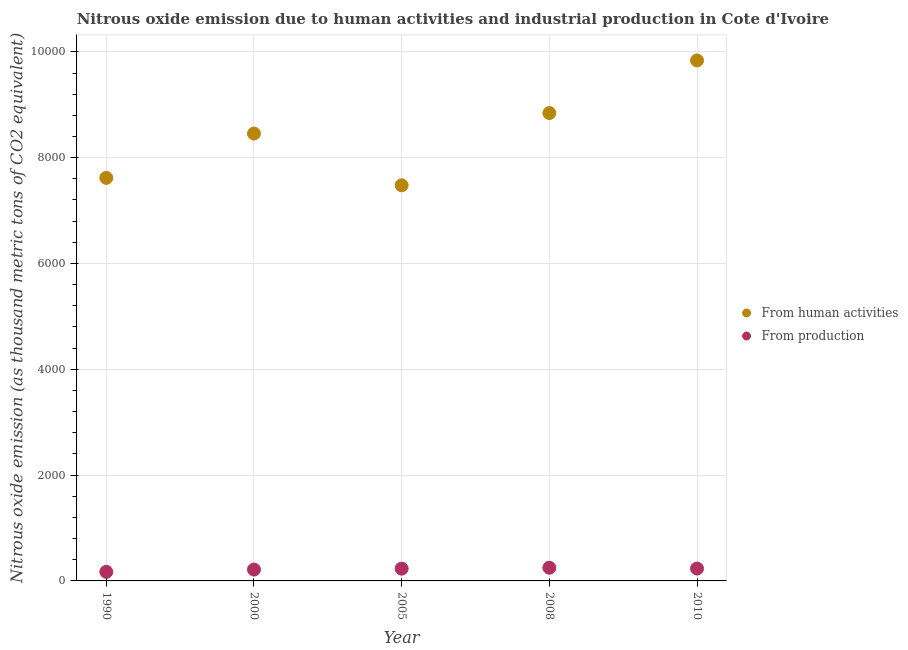Is the number of dotlines equal to the number of legend labels?
Your answer should be compact. Yes. What is the amount of emissions generated from industries in 2005?
Offer a very short reply. 231.8. Across all years, what is the maximum amount of emissions from human activities?
Your answer should be compact. 9837.4. Across all years, what is the minimum amount of emissions from human activities?
Provide a succinct answer. 7477.7. What is the total amount of emissions from human activities in the graph?
Make the answer very short. 4.22e+04. What is the difference between the amount of emissions from human activities in 2005 and that in 2010?
Ensure brevity in your answer.  -2359.7. What is the difference between the amount of emissions generated from industries in 1990 and the amount of emissions from human activities in 2005?
Offer a terse response. -7306.1. What is the average amount of emissions from human activities per year?
Offer a terse response. 8446.42. In the year 2008, what is the difference between the amount of emissions generated from industries and amount of emissions from human activities?
Offer a very short reply. -8594.1. What is the ratio of the amount of emissions generated from industries in 2005 to that in 2008?
Ensure brevity in your answer.  0.93. Is the difference between the amount of emissions from human activities in 1990 and 2010 greater than the difference between the amount of emissions generated from industries in 1990 and 2010?
Your response must be concise. No. What is the difference between the highest and the second highest amount of emissions from human activities?
Provide a short and direct response. 994.1. What is the difference between the highest and the lowest amount of emissions generated from industries?
Keep it short and to the point. 77.6. In how many years, is the amount of emissions generated from industries greater than the average amount of emissions generated from industries taken over all years?
Offer a very short reply. 3. Is the amount of emissions from human activities strictly greater than the amount of emissions generated from industries over the years?
Provide a short and direct response. Yes. What is the difference between two consecutive major ticks on the Y-axis?
Offer a terse response. 2000. How many legend labels are there?
Offer a terse response. 2. What is the title of the graph?
Offer a very short reply. Nitrous oxide emission due to human activities and industrial production in Cote d'Ivoire. What is the label or title of the Y-axis?
Make the answer very short. Nitrous oxide emission (as thousand metric tons of CO2 equivalent). What is the Nitrous oxide emission (as thousand metric tons of CO2 equivalent) in From human activities in 1990?
Keep it short and to the point. 7618. What is the Nitrous oxide emission (as thousand metric tons of CO2 equivalent) in From production in 1990?
Keep it short and to the point. 171.6. What is the Nitrous oxide emission (as thousand metric tons of CO2 equivalent) in From human activities in 2000?
Provide a succinct answer. 8455.7. What is the Nitrous oxide emission (as thousand metric tons of CO2 equivalent) of From production in 2000?
Provide a short and direct response. 214.7. What is the Nitrous oxide emission (as thousand metric tons of CO2 equivalent) of From human activities in 2005?
Offer a terse response. 7477.7. What is the Nitrous oxide emission (as thousand metric tons of CO2 equivalent) of From production in 2005?
Keep it short and to the point. 231.8. What is the Nitrous oxide emission (as thousand metric tons of CO2 equivalent) in From human activities in 2008?
Your answer should be compact. 8843.3. What is the Nitrous oxide emission (as thousand metric tons of CO2 equivalent) of From production in 2008?
Make the answer very short. 249.2. What is the Nitrous oxide emission (as thousand metric tons of CO2 equivalent) of From human activities in 2010?
Your response must be concise. 9837.4. What is the Nitrous oxide emission (as thousand metric tons of CO2 equivalent) in From production in 2010?
Offer a terse response. 233.8. Across all years, what is the maximum Nitrous oxide emission (as thousand metric tons of CO2 equivalent) in From human activities?
Your response must be concise. 9837.4. Across all years, what is the maximum Nitrous oxide emission (as thousand metric tons of CO2 equivalent) of From production?
Offer a very short reply. 249.2. Across all years, what is the minimum Nitrous oxide emission (as thousand metric tons of CO2 equivalent) in From human activities?
Provide a succinct answer. 7477.7. Across all years, what is the minimum Nitrous oxide emission (as thousand metric tons of CO2 equivalent) in From production?
Your response must be concise. 171.6. What is the total Nitrous oxide emission (as thousand metric tons of CO2 equivalent) in From human activities in the graph?
Offer a very short reply. 4.22e+04. What is the total Nitrous oxide emission (as thousand metric tons of CO2 equivalent) in From production in the graph?
Your response must be concise. 1101.1. What is the difference between the Nitrous oxide emission (as thousand metric tons of CO2 equivalent) of From human activities in 1990 and that in 2000?
Your response must be concise. -837.7. What is the difference between the Nitrous oxide emission (as thousand metric tons of CO2 equivalent) in From production in 1990 and that in 2000?
Your answer should be very brief. -43.1. What is the difference between the Nitrous oxide emission (as thousand metric tons of CO2 equivalent) in From human activities in 1990 and that in 2005?
Give a very brief answer. 140.3. What is the difference between the Nitrous oxide emission (as thousand metric tons of CO2 equivalent) in From production in 1990 and that in 2005?
Offer a terse response. -60.2. What is the difference between the Nitrous oxide emission (as thousand metric tons of CO2 equivalent) in From human activities in 1990 and that in 2008?
Provide a succinct answer. -1225.3. What is the difference between the Nitrous oxide emission (as thousand metric tons of CO2 equivalent) in From production in 1990 and that in 2008?
Your answer should be compact. -77.6. What is the difference between the Nitrous oxide emission (as thousand metric tons of CO2 equivalent) in From human activities in 1990 and that in 2010?
Your answer should be very brief. -2219.4. What is the difference between the Nitrous oxide emission (as thousand metric tons of CO2 equivalent) in From production in 1990 and that in 2010?
Give a very brief answer. -62.2. What is the difference between the Nitrous oxide emission (as thousand metric tons of CO2 equivalent) in From human activities in 2000 and that in 2005?
Provide a short and direct response. 978. What is the difference between the Nitrous oxide emission (as thousand metric tons of CO2 equivalent) of From production in 2000 and that in 2005?
Keep it short and to the point. -17.1. What is the difference between the Nitrous oxide emission (as thousand metric tons of CO2 equivalent) in From human activities in 2000 and that in 2008?
Your answer should be compact. -387.6. What is the difference between the Nitrous oxide emission (as thousand metric tons of CO2 equivalent) in From production in 2000 and that in 2008?
Give a very brief answer. -34.5. What is the difference between the Nitrous oxide emission (as thousand metric tons of CO2 equivalent) in From human activities in 2000 and that in 2010?
Your answer should be very brief. -1381.7. What is the difference between the Nitrous oxide emission (as thousand metric tons of CO2 equivalent) in From production in 2000 and that in 2010?
Provide a short and direct response. -19.1. What is the difference between the Nitrous oxide emission (as thousand metric tons of CO2 equivalent) in From human activities in 2005 and that in 2008?
Offer a terse response. -1365.6. What is the difference between the Nitrous oxide emission (as thousand metric tons of CO2 equivalent) in From production in 2005 and that in 2008?
Keep it short and to the point. -17.4. What is the difference between the Nitrous oxide emission (as thousand metric tons of CO2 equivalent) of From human activities in 2005 and that in 2010?
Give a very brief answer. -2359.7. What is the difference between the Nitrous oxide emission (as thousand metric tons of CO2 equivalent) in From production in 2005 and that in 2010?
Your answer should be very brief. -2. What is the difference between the Nitrous oxide emission (as thousand metric tons of CO2 equivalent) in From human activities in 2008 and that in 2010?
Offer a very short reply. -994.1. What is the difference between the Nitrous oxide emission (as thousand metric tons of CO2 equivalent) of From human activities in 1990 and the Nitrous oxide emission (as thousand metric tons of CO2 equivalent) of From production in 2000?
Provide a short and direct response. 7403.3. What is the difference between the Nitrous oxide emission (as thousand metric tons of CO2 equivalent) of From human activities in 1990 and the Nitrous oxide emission (as thousand metric tons of CO2 equivalent) of From production in 2005?
Make the answer very short. 7386.2. What is the difference between the Nitrous oxide emission (as thousand metric tons of CO2 equivalent) of From human activities in 1990 and the Nitrous oxide emission (as thousand metric tons of CO2 equivalent) of From production in 2008?
Provide a short and direct response. 7368.8. What is the difference between the Nitrous oxide emission (as thousand metric tons of CO2 equivalent) in From human activities in 1990 and the Nitrous oxide emission (as thousand metric tons of CO2 equivalent) in From production in 2010?
Your response must be concise. 7384.2. What is the difference between the Nitrous oxide emission (as thousand metric tons of CO2 equivalent) in From human activities in 2000 and the Nitrous oxide emission (as thousand metric tons of CO2 equivalent) in From production in 2005?
Offer a very short reply. 8223.9. What is the difference between the Nitrous oxide emission (as thousand metric tons of CO2 equivalent) in From human activities in 2000 and the Nitrous oxide emission (as thousand metric tons of CO2 equivalent) in From production in 2008?
Make the answer very short. 8206.5. What is the difference between the Nitrous oxide emission (as thousand metric tons of CO2 equivalent) of From human activities in 2000 and the Nitrous oxide emission (as thousand metric tons of CO2 equivalent) of From production in 2010?
Keep it short and to the point. 8221.9. What is the difference between the Nitrous oxide emission (as thousand metric tons of CO2 equivalent) of From human activities in 2005 and the Nitrous oxide emission (as thousand metric tons of CO2 equivalent) of From production in 2008?
Your response must be concise. 7228.5. What is the difference between the Nitrous oxide emission (as thousand metric tons of CO2 equivalent) in From human activities in 2005 and the Nitrous oxide emission (as thousand metric tons of CO2 equivalent) in From production in 2010?
Give a very brief answer. 7243.9. What is the difference between the Nitrous oxide emission (as thousand metric tons of CO2 equivalent) of From human activities in 2008 and the Nitrous oxide emission (as thousand metric tons of CO2 equivalent) of From production in 2010?
Offer a terse response. 8609.5. What is the average Nitrous oxide emission (as thousand metric tons of CO2 equivalent) in From human activities per year?
Your answer should be compact. 8446.42. What is the average Nitrous oxide emission (as thousand metric tons of CO2 equivalent) in From production per year?
Your answer should be compact. 220.22. In the year 1990, what is the difference between the Nitrous oxide emission (as thousand metric tons of CO2 equivalent) in From human activities and Nitrous oxide emission (as thousand metric tons of CO2 equivalent) in From production?
Your response must be concise. 7446.4. In the year 2000, what is the difference between the Nitrous oxide emission (as thousand metric tons of CO2 equivalent) in From human activities and Nitrous oxide emission (as thousand metric tons of CO2 equivalent) in From production?
Ensure brevity in your answer.  8241. In the year 2005, what is the difference between the Nitrous oxide emission (as thousand metric tons of CO2 equivalent) in From human activities and Nitrous oxide emission (as thousand metric tons of CO2 equivalent) in From production?
Offer a terse response. 7245.9. In the year 2008, what is the difference between the Nitrous oxide emission (as thousand metric tons of CO2 equivalent) in From human activities and Nitrous oxide emission (as thousand metric tons of CO2 equivalent) in From production?
Provide a short and direct response. 8594.1. In the year 2010, what is the difference between the Nitrous oxide emission (as thousand metric tons of CO2 equivalent) in From human activities and Nitrous oxide emission (as thousand metric tons of CO2 equivalent) in From production?
Offer a terse response. 9603.6. What is the ratio of the Nitrous oxide emission (as thousand metric tons of CO2 equivalent) of From human activities in 1990 to that in 2000?
Offer a terse response. 0.9. What is the ratio of the Nitrous oxide emission (as thousand metric tons of CO2 equivalent) in From production in 1990 to that in 2000?
Keep it short and to the point. 0.8. What is the ratio of the Nitrous oxide emission (as thousand metric tons of CO2 equivalent) in From human activities in 1990 to that in 2005?
Offer a very short reply. 1.02. What is the ratio of the Nitrous oxide emission (as thousand metric tons of CO2 equivalent) of From production in 1990 to that in 2005?
Your answer should be very brief. 0.74. What is the ratio of the Nitrous oxide emission (as thousand metric tons of CO2 equivalent) of From human activities in 1990 to that in 2008?
Offer a very short reply. 0.86. What is the ratio of the Nitrous oxide emission (as thousand metric tons of CO2 equivalent) of From production in 1990 to that in 2008?
Offer a very short reply. 0.69. What is the ratio of the Nitrous oxide emission (as thousand metric tons of CO2 equivalent) in From human activities in 1990 to that in 2010?
Give a very brief answer. 0.77. What is the ratio of the Nitrous oxide emission (as thousand metric tons of CO2 equivalent) of From production in 1990 to that in 2010?
Offer a terse response. 0.73. What is the ratio of the Nitrous oxide emission (as thousand metric tons of CO2 equivalent) of From human activities in 2000 to that in 2005?
Provide a succinct answer. 1.13. What is the ratio of the Nitrous oxide emission (as thousand metric tons of CO2 equivalent) of From production in 2000 to that in 2005?
Make the answer very short. 0.93. What is the ratio of the Nitrous oxide emission (as thousand metric tons of CO2 equivalent) in From human activities in 2000 to that in 2008?
Offer a very short reply. 0.96. What is the ratio of the Nitrous oxide emission (as thousand metric tons of CO2 equivalent) of From production in 2000 to that in 2008?
Make the answer very short. 0.86. What is the ratio of the Nitrous oxide emission (as thousand metric tons of CO2 equivalent) in From human activities in 2000 to that in 2010?
Your answer should be very brief. 0.86. What is the ratio of the Nitrous oxide emission (as thousand metric tons of CO2 equivalent) in From production in 2000 to that in 2010?
Make the answer very short. 0.92. What is the ratio of the Nitrous oxide emission (as thousand metric tons of CO2 equivalent) of From human activities in 2005 to that in 2008?
Offer a very short reply. 0.85. What is the ratio of the Nitrous oxide emission (as thousand metric tons of CO2 equivalent) in From production in 2005 to that in 2008?
Offer a very short reply. 0.93. What is the ratio of the Nitrous oxide emission (as thousand metric tons of CO2 equivalent) in From human activities in 2005 to that in 2010?
Your answer should be very brief. 0.76. What is the ratio of the Nitrous oxide emission (as thousand metric tons of CO2 equivalent) in From human activities in 2008 to that in 2010?
Your answer should be compact. 0.9. What is the ratio of the Nitrous oxide emission (as thousand metric tons of CO2 equivalent) in From production in 2008 to that in 2010?
Provide a succinct answer. 1.07. What is the difference between the highest and the second highest Nitrous oxide emission (as thousand metric tons of CO2 equivalent) of From human activities?
Your answer should be very brief. 994.1. What is the difference between the highest and the second highest Nitrous oxide emission (as thousand metric tons of CO2 equivalent) of From production?
Give a very brief answer. 15.4. What is the difference between the highest and the lowest Nitrous oxide emission (as thousand metric tons of CO2 equivalent) in From human activities?
Offer a very short reply. 2359.7. What is the difference between the highest and the lowest Nitrous oxide emission (as thousand metric tons of CO2 equivalent) in From production?
Give a very brief answer. 77.6. 